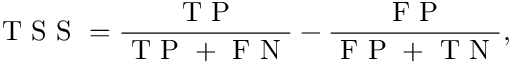Convert formula to latex. <formula><loc_0><loc_0><loc_500><loc_500>T S S = \frac { T P } { T P + F N } - \frac { F P } { F P + T N } ,</formula> 